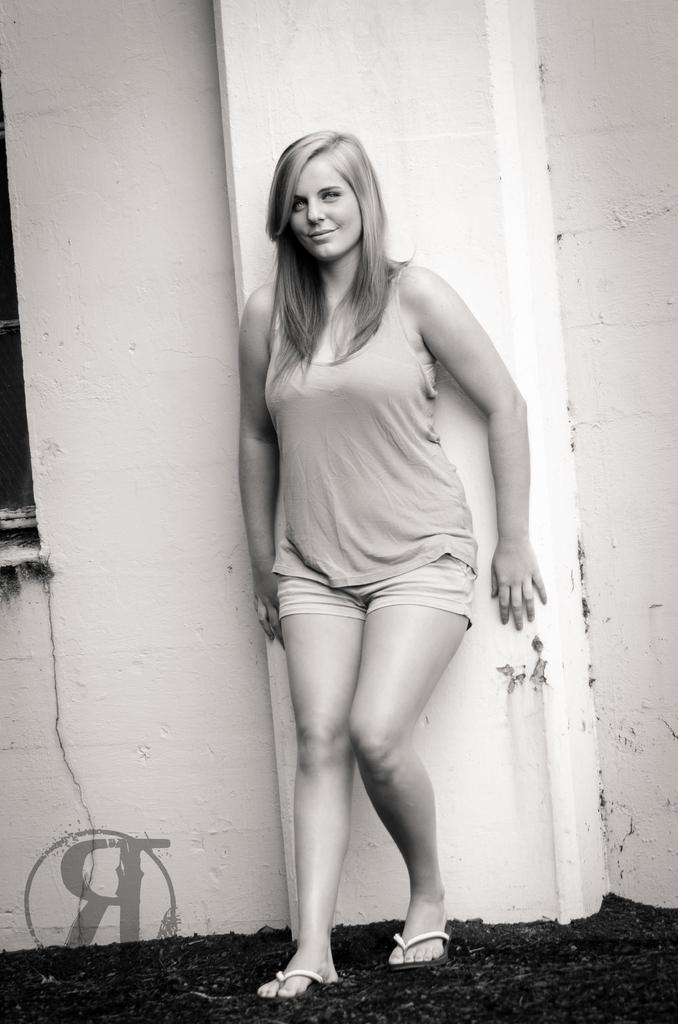Who is present in the image? There is a woman in the image. What is the woman doing in the image? The woman is standing in the image. What is the woman's facial expression in the image? The woman is smiling in the image. What can be seen behind the woman in the image? There is a wall behind the woman in the image. Where is the faucet located in the image? There is no faucet present in the image. What color is the balloon that the woman is holding in the image? There is no balloon present in the image. 